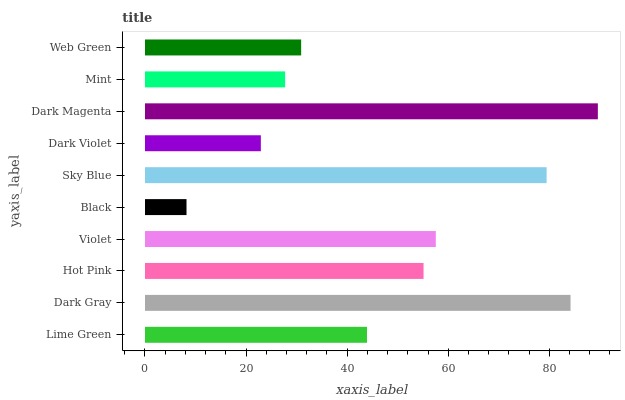Is Black the minimum?
Answer yes or no. Yes. Is Dark Magenta the maximum?
Answer yes or no. Yes. Is Dark Gray the minimum?
Answer yes or no. No. Is Dark Gray the maximum?
Answer yes or no. No. Is Dark Gray greater than Lime Green?
Answer yes or no. Yes. Is Lime Green less than Dark Gray?
Answer yes or no. Yes. Is Lime Green greater than Dark Gray?
Answer yes or no. No. Is Dark Gray less than Lime Green?
Answer yes or no. No. Is Hot Pink the high median?
Answer yes or no. Yes. Is Lime Green the low median?
Answer yes or no. Yes. Is Dark Magenta the high median?
Answer yes or no. No. Is Mint the low median?
Answer yes or no. No. 